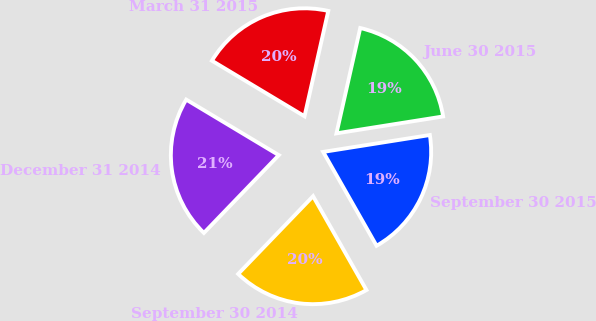Convert chart. <chart><loc_0><loc_0><loc_500><loc_500><pie_chart><fcel>September 30 2015<fcel>June 30 2015<fcel>March 31 2015<fcel>December 31 2014<fcel>September 30 2014<nl><fcel>19.27%<fcel>18.97%<fcel>19.93%<fcel>21.4%<fcel>20.43%<nl></chart> 